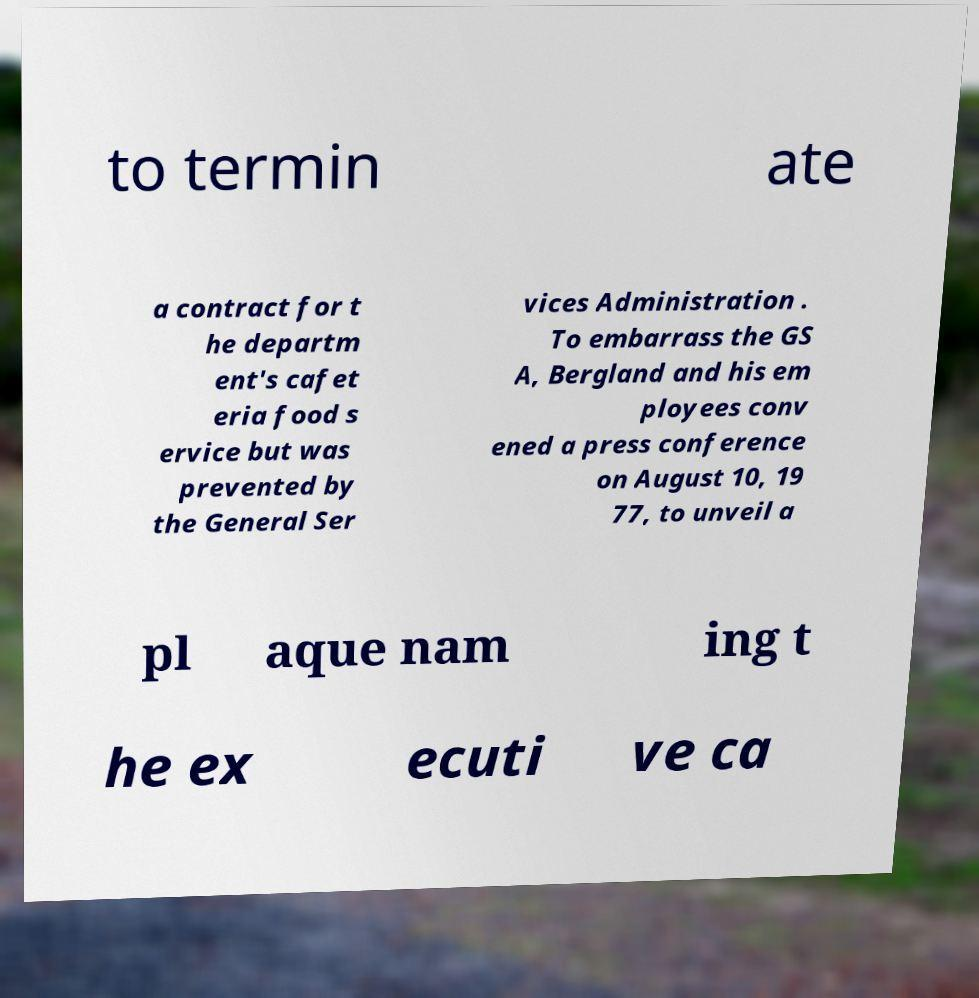Please read and relay the text visible in this image. What does it say? to termin ate a contract for t he departm ent's cafet eria food s ervice but was prevented by the General Ser vices Administration . To embarrass the GS A, Bergland and his em ployees conv ened a press conference on August 10, 19 77, to unveil a pl aque nam ing t he ex ecuti ve ca 